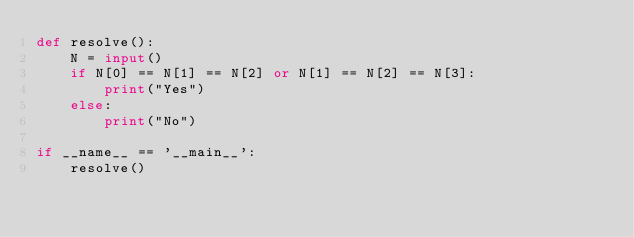<code> <loc_0><loc_0><loc_500><loc_500><_Python_>def resolve():
    N = input()
    if N[0] == N[1] == N[2] or N[1] == N[2] == N[3]:
        print("Yes")
    else:
        print("No")

if __name__ == '__main__':
    resolve()</code> 